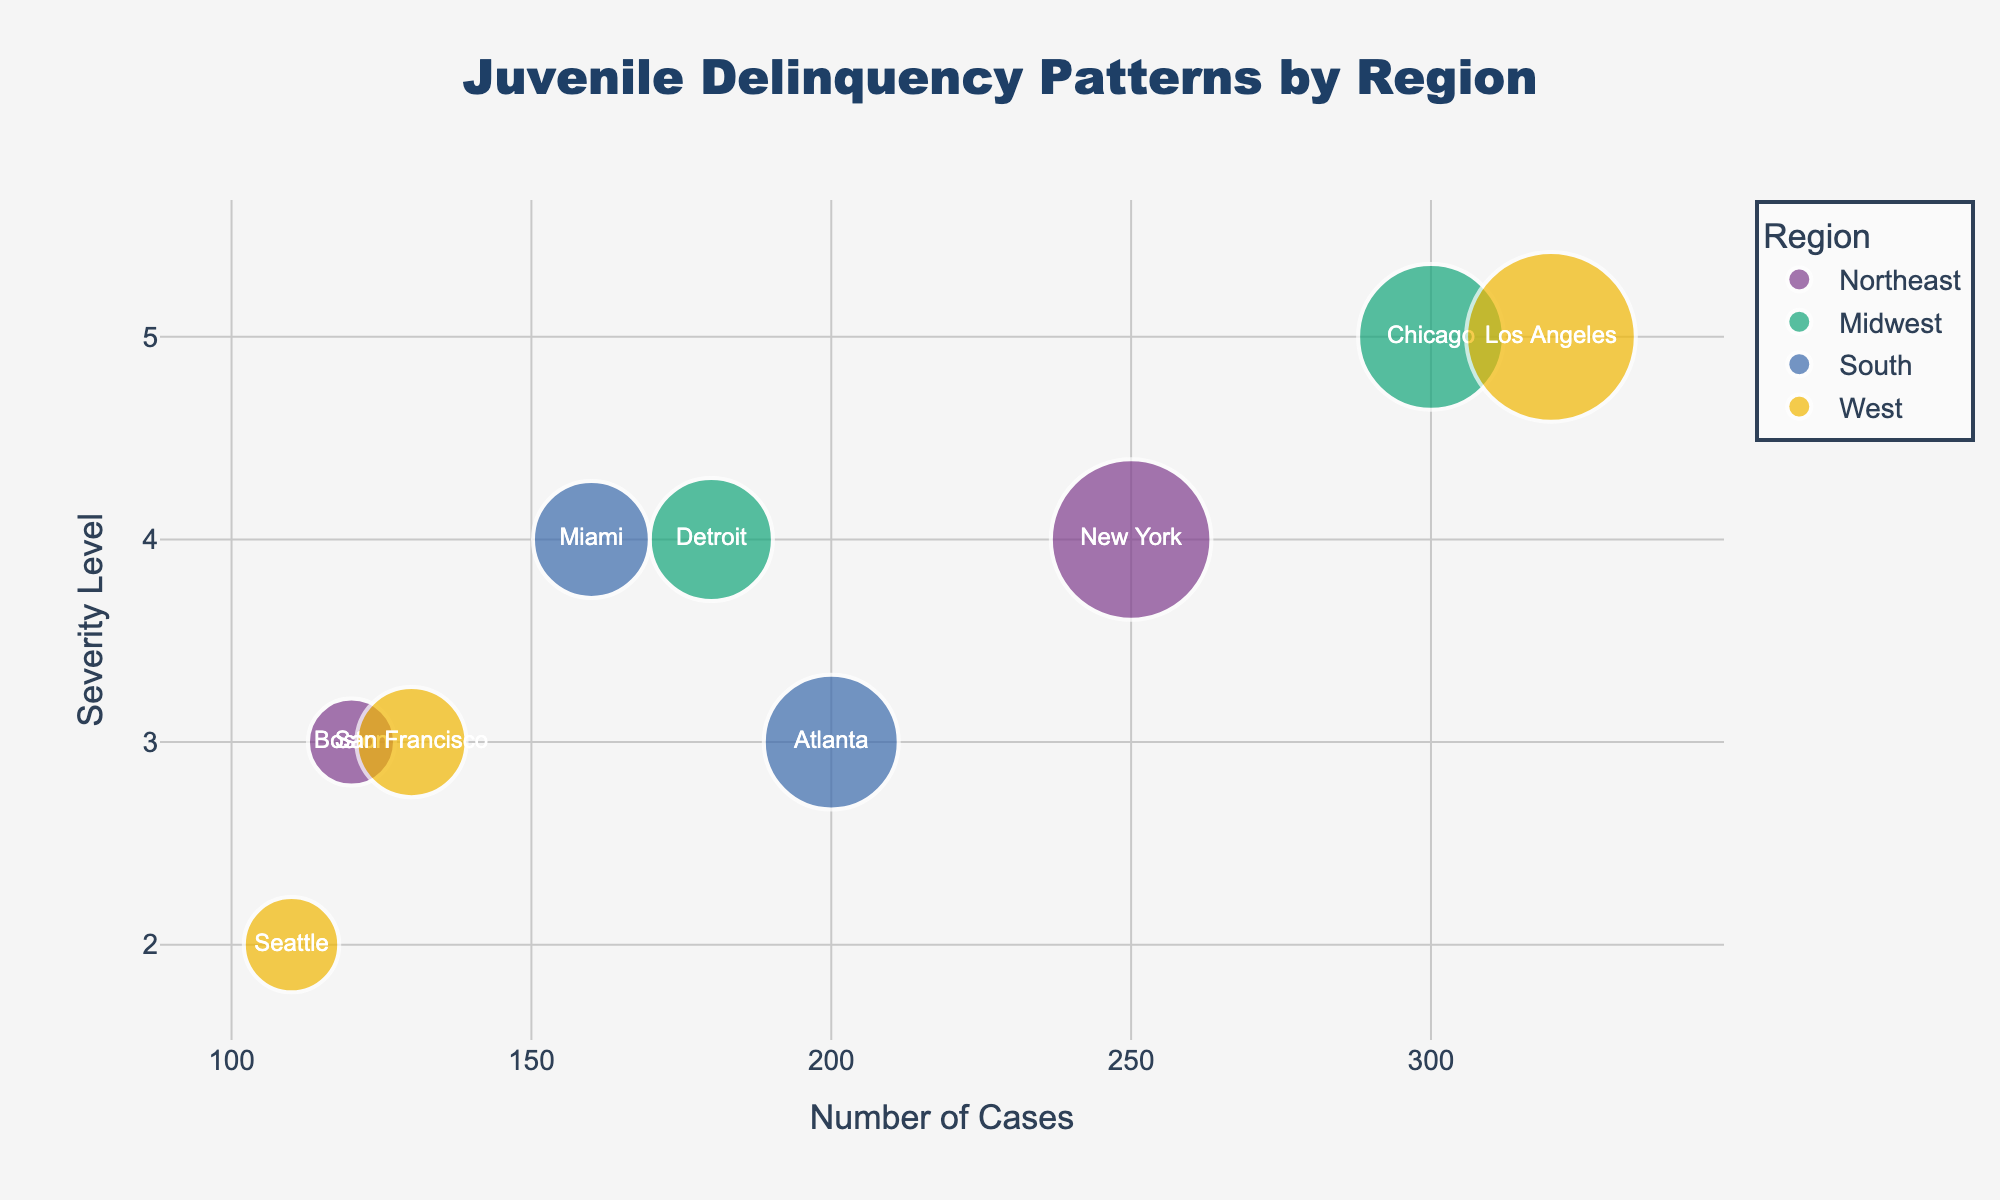What is the title of the figure? The title is located at the top center of the chart, which gives a summary of what the chart represents.
Answer: Juvenile Delinquency Patterns by Region How many data points (cities) are there in the chart? Count each city represented by a bubble in the chart.
Answer: 9 Which city has the highest number of juvenile delinquency cases? Look for the bubble positioned farthest to the right along the x-axis, which represents the number of cases.
Answer: Los Angeles Which city has the lowest severity level of juvenile delinquency? Look for the bubble positioned lowest along the y-axis, which represents the severity level.
Answer: Seattle What is the average severity level of cities in the Midwest region? Identify the cities in the Midwest region (Chicago and Detroit), sum their severity levels, and divide by the number of cities. (5 + 4) / 2 = 4.5
Answer: 4.5 Compare the number of juvenile delinquency cases between New York and Atlanta. Compare the x-axis position of the bubbles for New York and Atlanta.
Answer: New York has more cases than Atlanta Which region has the highest bubble size, and what might that indicate? Look for the region with the largest bubbles, which corresponds to the largest youth population.
Answer: West Which region has the highest average severity level? Identify and average the severity levels of the cities within each region, then compare the average values. The West region (Los Angeles: 5, San Francisco: 3, Seattle: 2) has an average of (5 + 3 + 2) / 3 = 3.33, which is lower than the Midwest (4.5) but higher than Northeast and South.
Answer: Midwest What is the total youth population in the Northeast region? Sum the youth population values for the cities in the Northeast region (New York and Boston): 850,000 + 250,000 = 1,100,000
Answer: 1,100,000 Which city has a higher severity level of juvenile delinquency, Miami or Detroit? Compare the y-axis positions of the bubbles for Miami and Detroit.
Answer: Both have a severity level of 4 